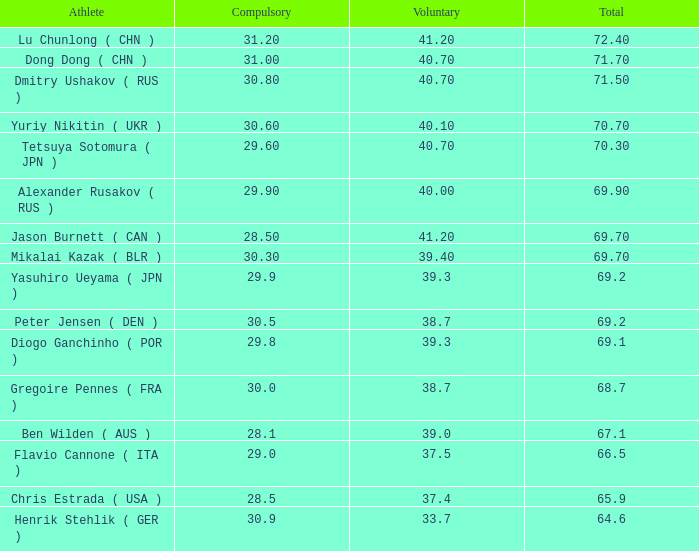What is the total obligatory value when the combined amount goes beyond 69.2 and the voluntary part is 38.7? 0.0. 